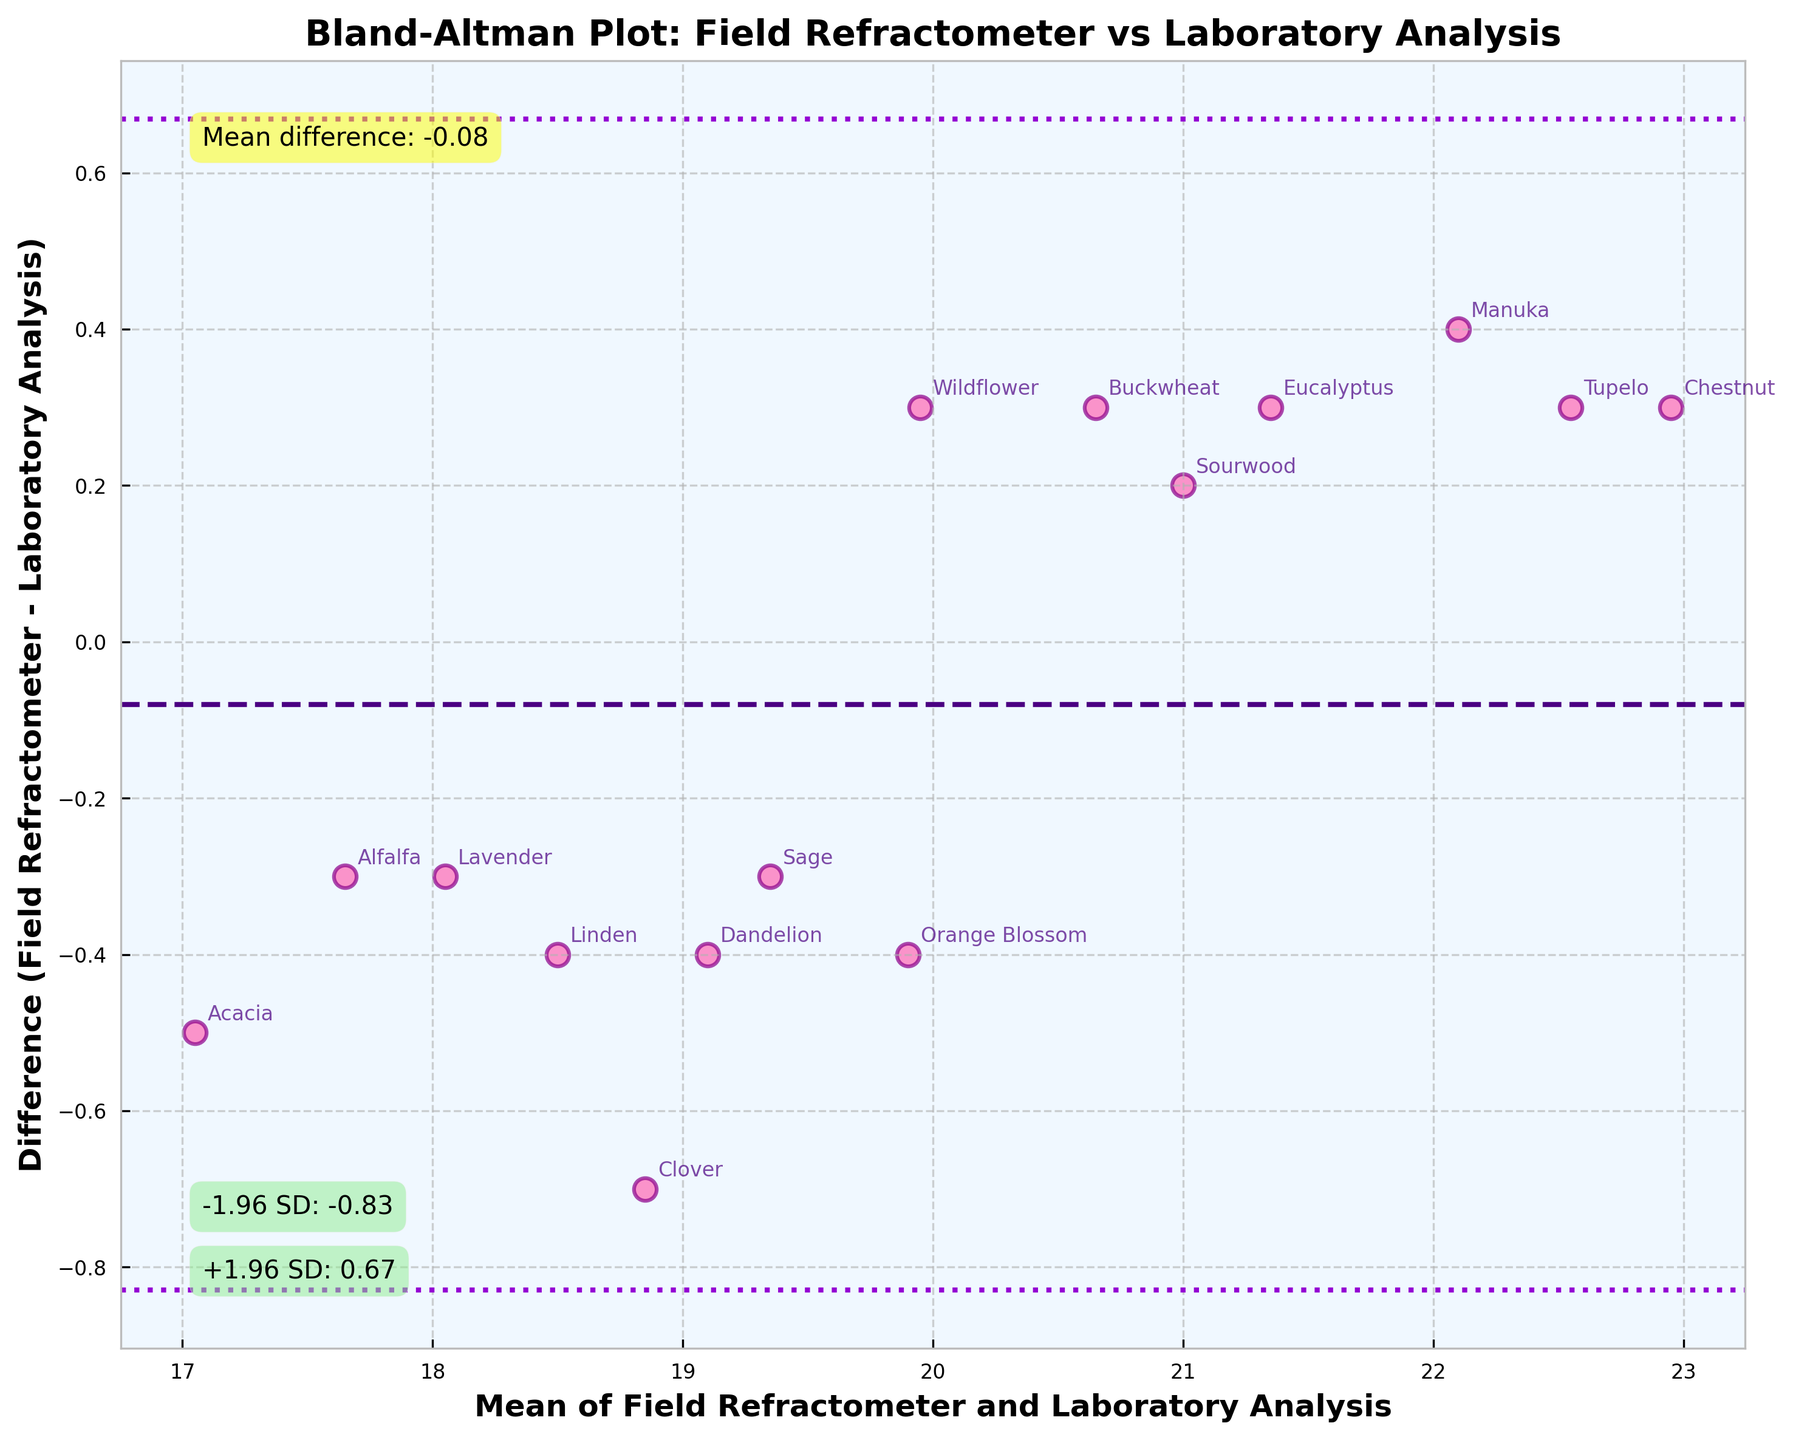Which honey type has the highest mean value on the x-axis? The mean value is calculated as the average of the Field Refractometer and Laboratory Analysis readings. On the Bland-Altman plot, we can see that the Chestnut honey type is located at the far right, indicating that it has the highest mean value.
Answer: Chestnut What is the title of the plot? The title of the plot is displayed at the top and it reads 'Bland-Altman Plot: Field Refractometer vs Laboratory Analysis'.
Answer: Bland-Altman Plot: Field Refractometer vs Laboratory Analysis How many data points are there on the plot? The plot includes one marker for each honey type, and there are 15 honey types listed in the data, so there should be 15 data points.
Answer: 15 What does the dashed line represent? The dashed line in the Bland-Altman plot represents the mean difference between the Field Refractometer and Laboratory Analysis readings, shown in a consistent color and located centrally among the data points.
Answer: Mean difference Which honey type has the largest positive difference on the y-axis? The difference is calculated as the Field Refractometer reading minus the Laboratory Analysis reading. By looking at the highest point on the y-axis, we identify Clover having the largest positive difference because it is positioned highest among the data points.
Answer: Clover What are the values of the limits of agreement? The values of the limits of agreement are annotated on the plot with +1.96 SD and -1.96 SD labels. By locating these annotations, we can see that the values are approximately 1.18 and -0.82, respectively.
Answer: +1.96 SD: 1.18, -1.96 SD: -0.82 Which honey type is closest to the mean difference line? The mean difference line is the dashed line, and the data point that is closest to this line is the one with a very small difference value. By inspection, Alfalfa is the closest to the mean difference line.
Answer: Alfalfa How does the spread of differences change as the mean increases? By observing the spread of points in the plot, we can determine that there appears to be a consistent spread of differences across all mean values, without a visible trend of increasing or decreasing differences with increasing mean values.
Answer: Consistent spread Which honey type has the smallest negative difference on the y-axis? To find the smallest negative difference, we look for the point closest to the dashed mean line but still under it. Acacia is slightly below the mean difference line, representing the smallest negative difference.
Answer: Acacia What is the mean difference value? The mean difference value is annotated on the plot's dashed line, which we can read directly as approximately 0.18.
Answer: 0.18 